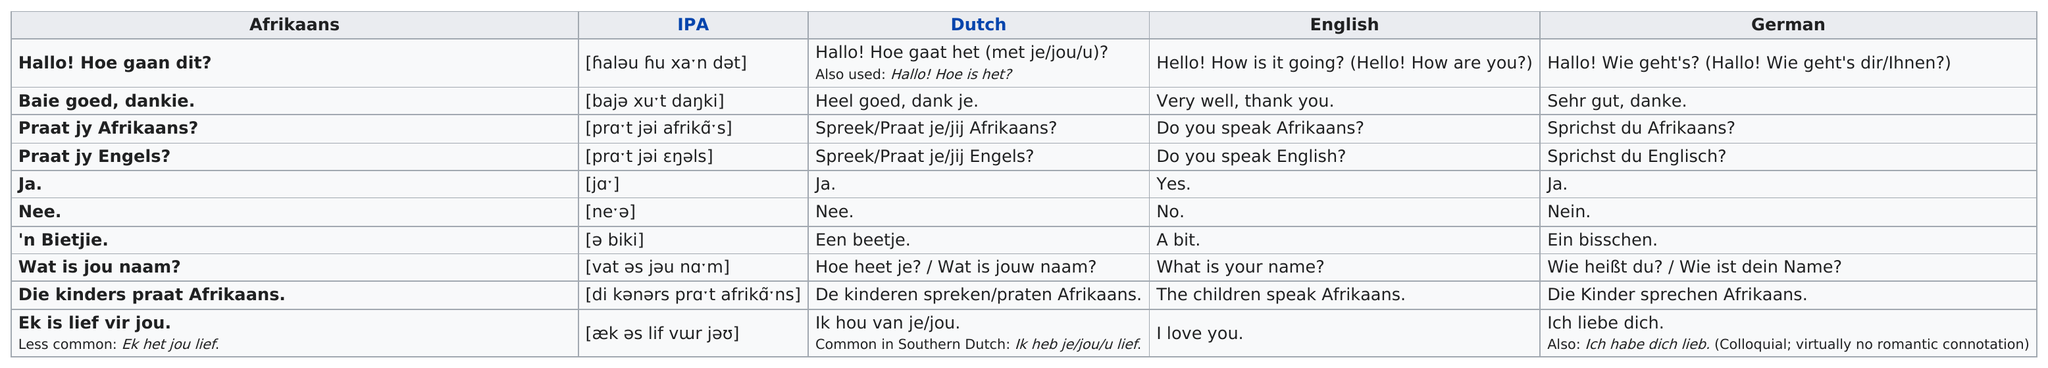Give some essential details in this illustration. I, being in love with you, say, 'I love you.' I am able to confirm that 'yes' is translated to 'Ja' in Afrikaans. The translation of 'n bietjie.? A bit... is 'a little' in English. I ask, 'Do you speak Afrikaans?' in Afrikaans. Ik wil weten of jy Afrikaans spreek, hier is mijn vraag in Afrikaans: 'Praat jy Afrikaans?' 